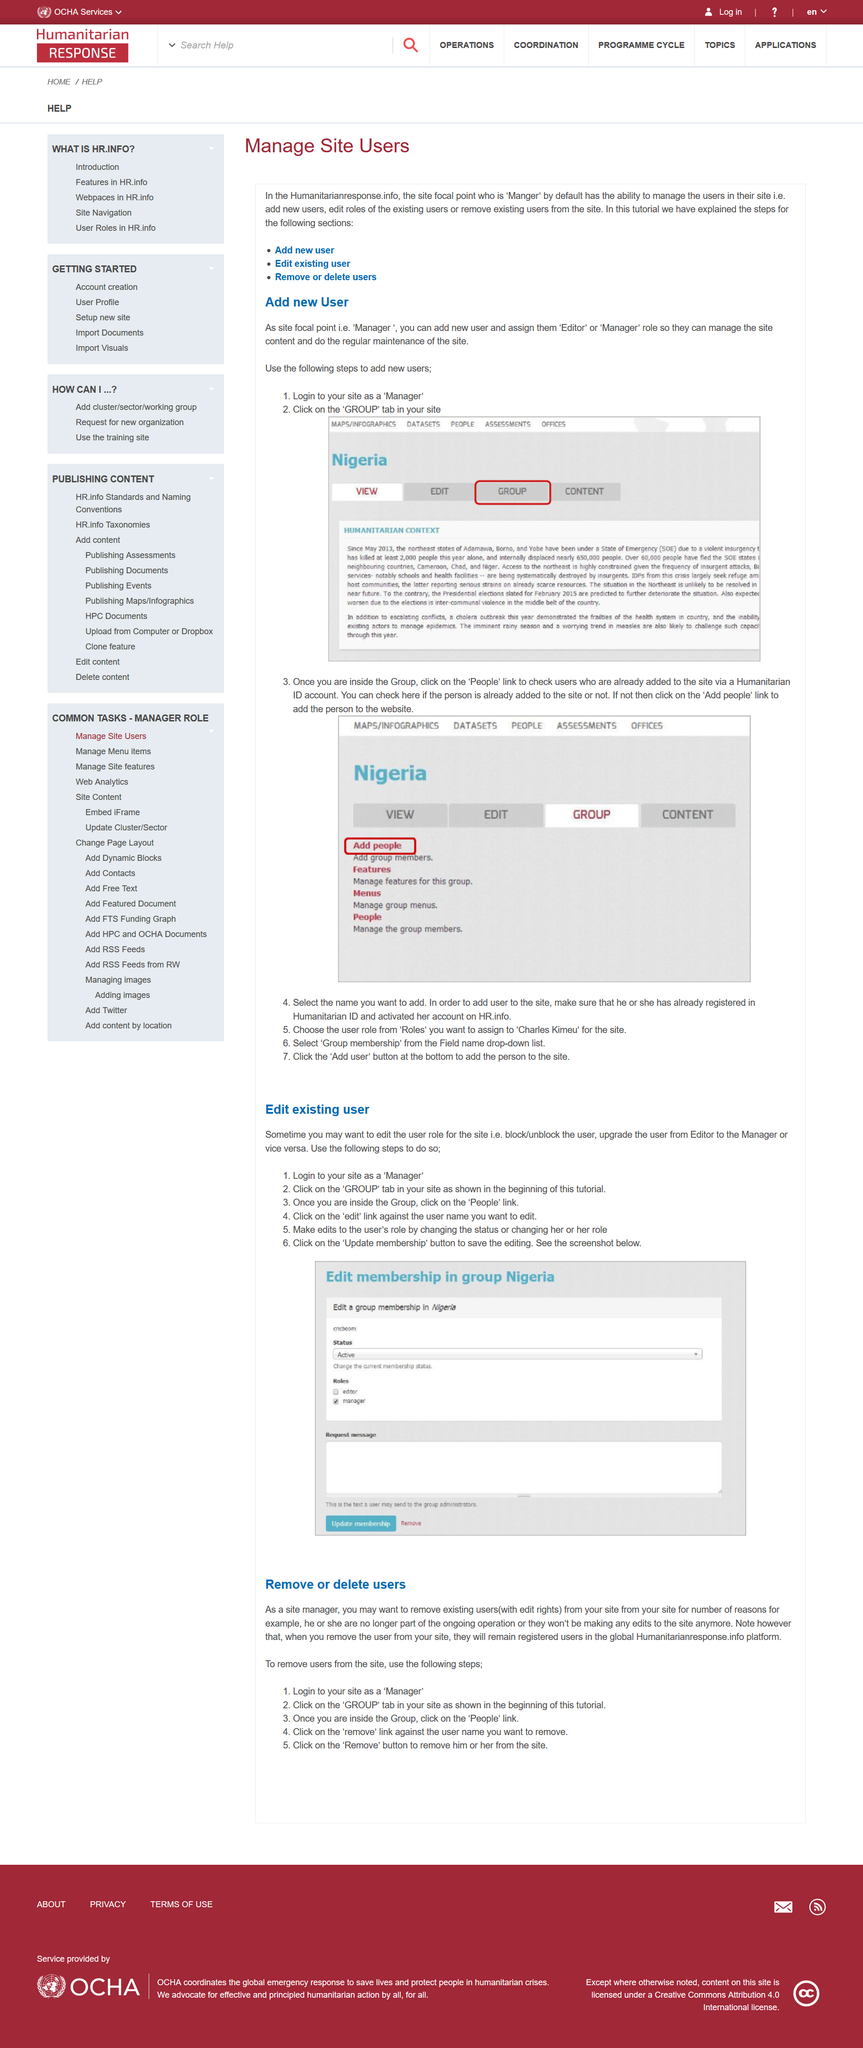List a handful of essential elements in this visual. To add a new user, it is necessary to log in as a Manager. In the second step, you should click on the GROUP tab to add a new user. To add a person to the website, click on the 'Add people' link. To block or unblock a user from accessing your website, the first step is to log in as the "manager" user and take the necessary actions. To determine whether a user has already been added to the site, click on the "People" link. 